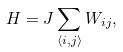Convert formula to latex. <formula><loc_0><loc_0><loc_500><loc_500>H = J \sum _ { \langle i , j \rangle } W _ { i j } ,</formula> 